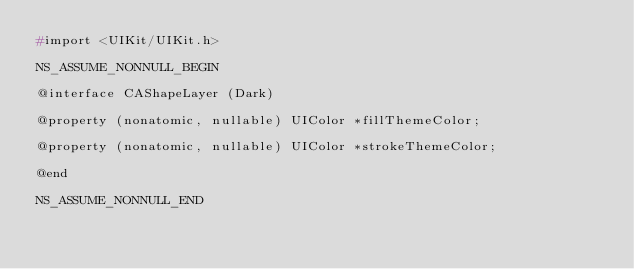<code> <loc_0><loc_0><loc_500><loc_500><_C_>#import <UIKit/UIKit.h>

NS_ASSUME_NONNULL_BEGIN

@interface CAShapeLayer (Dark)

@property (nonatomic, nullable) UIColor *fillThemeColor;

@property (nonatomic, nullable) UIColor *strokeThemeColor;

@end

NS_ASSUME_NONNULL_END
</code> 